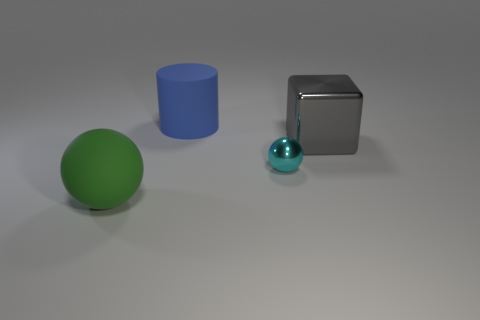Add 4 blue balls. How many objects exist? 8 Subtract all cubes. How many objects are left? 3 Add 2 small green rubber spheres. How many small green rubber spheres exist? 2 Subtract 1 cyan spheres. How many objects are left? 3 Subtract all big things. Subtract all blue balls. How many objects are left? 1 Add 4 shiny blocks. How many shiny blocks are left? 5 